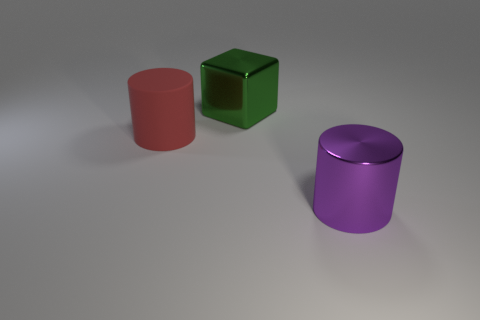Add 1 big things. How many objects exist? 4 Subtract all blocks. How many objects are left? 2 Subtract 1 purple cylinders. How many objects are left? 2 Subtract all big gray cylinders. Subtract all big metallic blocks. How many objects are left? 2 Add 1 green metallic things. How many green metallic things are left? 2 Add 1 rubber cylinders. How many rubber cylinders exist? 2 